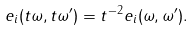<formula> <loc_0><loc_0><loc_500><loc_500>e _ { i } ( t \omega , t \omega ^ { \prime } ) = t ^ { - 2 } e _ { i } ( \omega , \omega ^ { \prime } ) .</formula> 